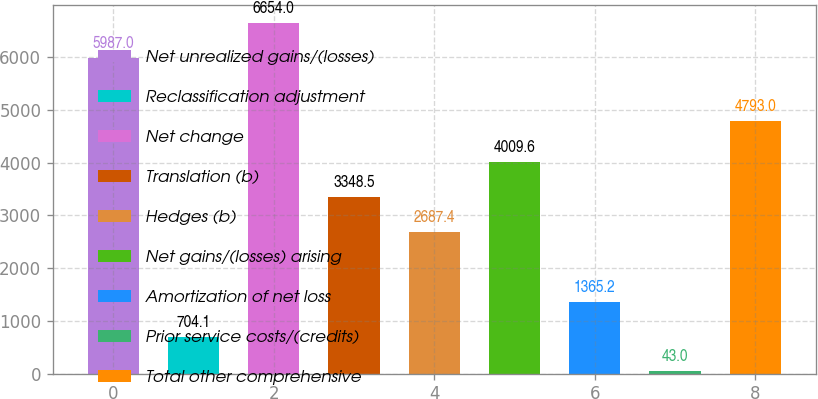<chart> <loc_0><loc_0><loc_500><loc_500><bar_chart><fcel>Net unrealized gains/(losses)<fcel>Reclassification adjustment<fcel>Net change<fcel>Translation (b)<fcel>Hedges (b)<fcel>Net gains/(losses) arising<fcel>Amortization of net loss<fcel>Prior service costs/(credits)<fcel>Total other comprehensive<nl><fcel>5987<fcel>704.1<fcel>6654<fcel>3348.5<fcel>2687.4<fcel>4009.6<fcel>1365.2<fcel>43<fcel>4793<nl></chart> 